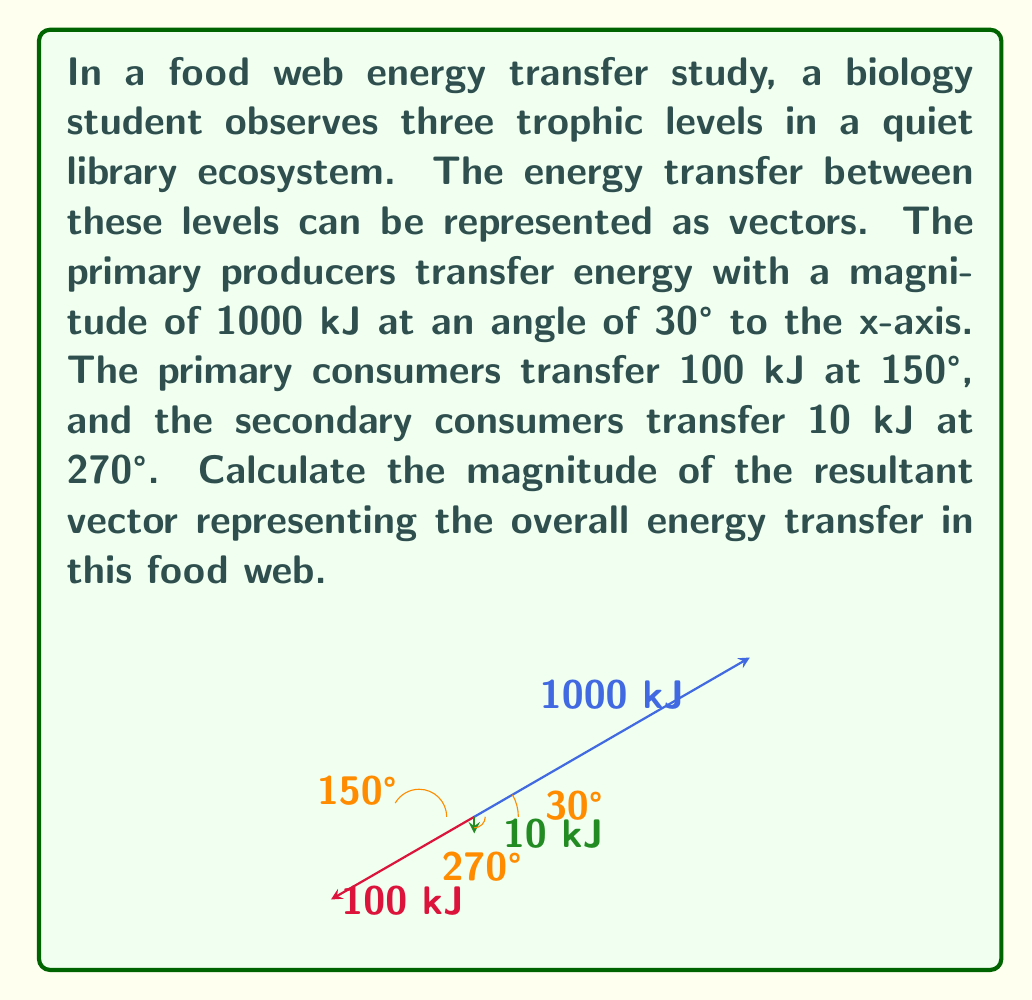Give your solution to this math problem. To solve this problem, we'll use vector addition and the magnitude formula. Let's break it down step-by-step:

1) First, let's convert each vector to its x and y components:

   Vector 1 (Primary producers):
   $x_1 = 1000 \cos(30°) = 866.03$ kJ
   $y_1 = 1000 \sin(30°) = 500$ kJ

   Vector 2 (Primary consumers):
   $x_2 = 100 \cos(150°) = -86.60$ kJ
   $y_2 = 100 \sin(150°) = 50$ kJ

   Vector 3 (Secondary consumers):
   $x_3 = 10 \cos(270°) = 0$ kJ
   $y_3 = 10 \sin(270°) = -10$ kJ

2) Now, we sum up all the x components and all the y components:

   $x_{total} = x_1 + x_2 + x_3 = 866.03 + (-86.60) + 0 = 779.43$ kJ
   $y_{total} = y_1 + y_2 + y_3 = 500 + 50 + (-10) = 540$ kJ

3) The resultant vector is $(779.43, 540)$ kJ

4) To find the magnitude of this vector, we use the Pythagorean theorem:

   $magnitude = \sqrt{x_{total}^2 + y_{total}^2}$

5) Substituting our values:

   $magnitude = \sqrt{779.43^2 + 540^2}$

6) Calculate:

   $magnitude = \sqrt{607,511.49 + 291,600} = \sqrt{899,111.49} \approx 948.21$ kJ

Therefore, the magnitude of the resultant vector representing the overall energy transfer in this food web is approximately 948.21 kJ.
Answer: $948.21$ kJ 